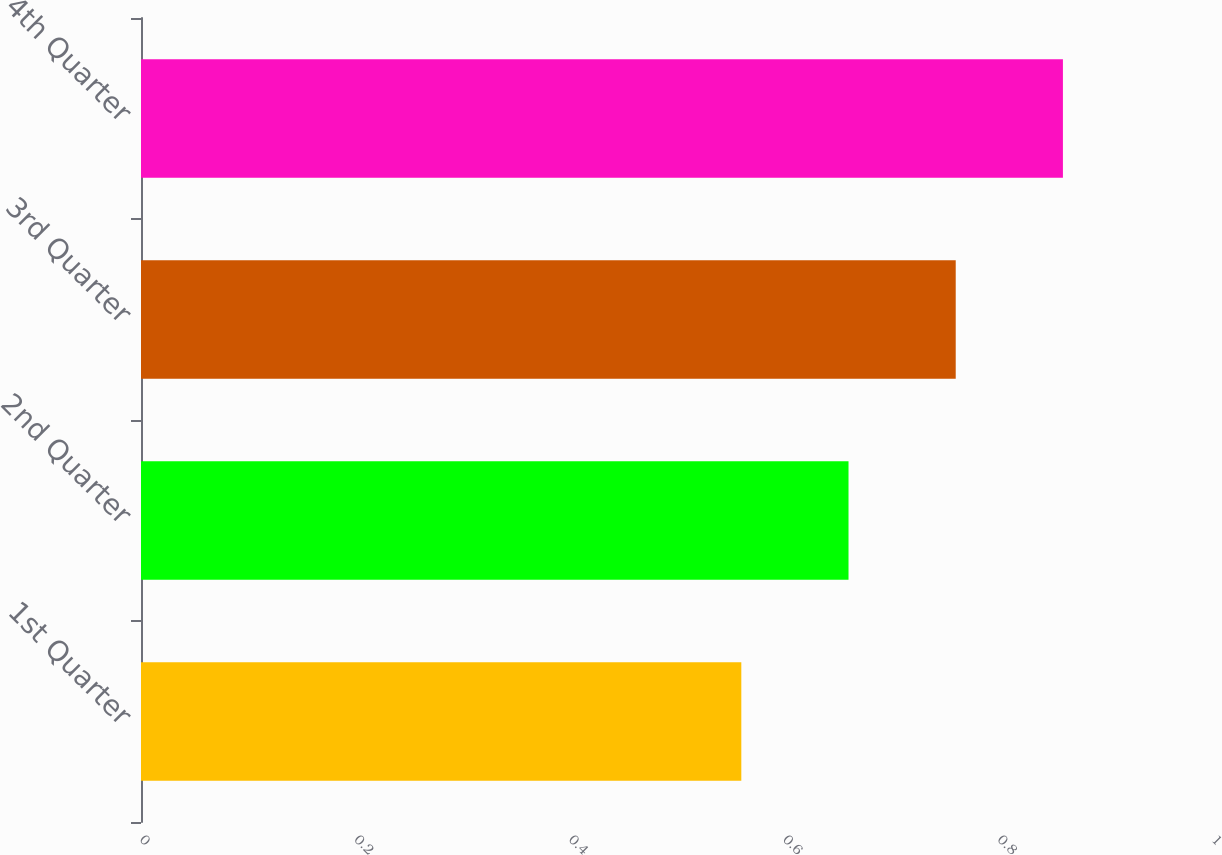Convert chart. <chart><loc_0><loc_0><loc_500><loc_500><bar_chart><fcel>1st Quarter<fcel>2nd Quarter<fcel>3rd Quarter<fcel>4th Quarter<nl><fcel>0.56<fcel>0.66<fcel>0.76<fcel>0.86<nl></chart> 